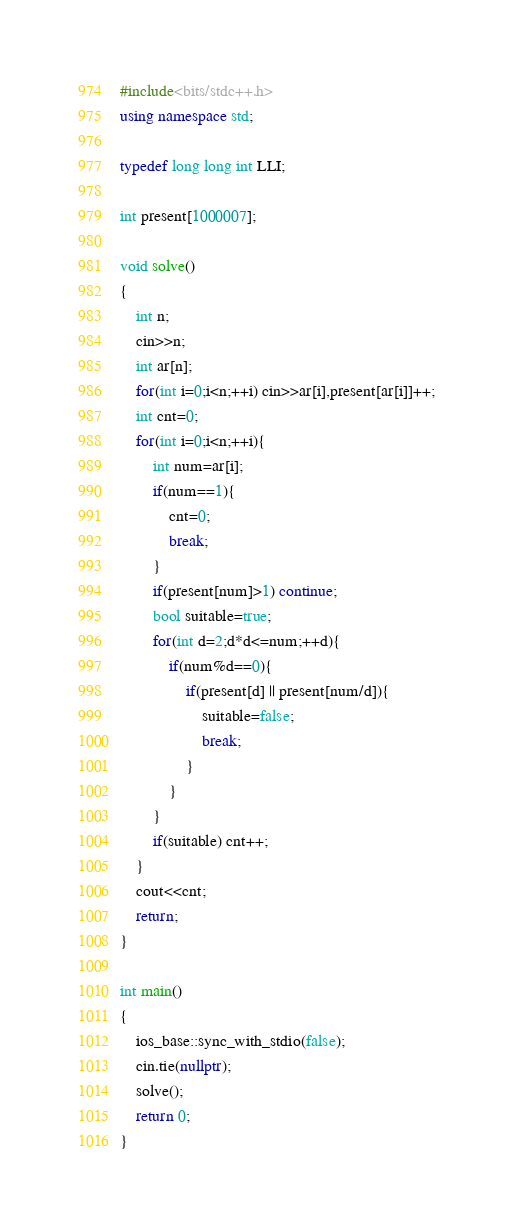Convert code to text. <code><loc_0><loc_0><loc_500><loc_500><_C++_>#include<bits/stdc++.h>
using namespace std;

typedef long long int LLI;

int present[1000007];

void solve()
{
    int n;
    cin>>n;
    int ar[n];
    for(int i=0;i<n;++i) cin>>ar[i],present[ar[i]]++;
    int cnt=0;
    for(int i=0;i<n;++i){
        int num=ar[i];
        if(num==1){
            cnt=0;
            break;
        }
        if(present[num]>1) continue;
        bool suitable=true;
        for(int d=2;d*d<=num;++d){
            if(num%d==0){
                if(present[d] || present[num/d]){
                    suitable=false;
                    break;
                }
            }
        }
        if(suitable) cnt++;
    }
    cout<<cnt;
    return;
}

int main()
{
    ios_base::sync_with_stdio(false);
    cin.tie(nullptr);
    solve();
    return 0;
}</code> 